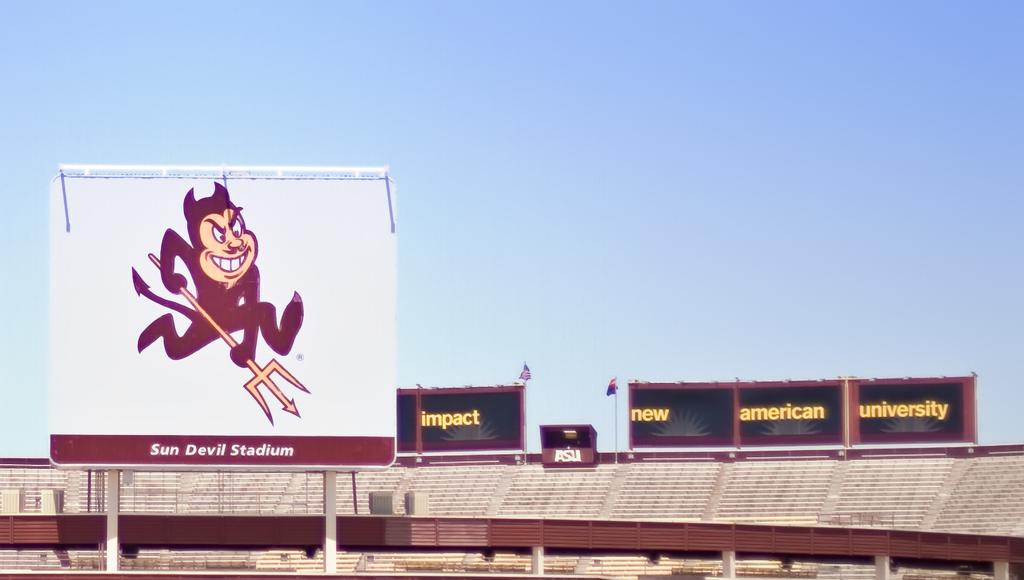What is the name of the stadium?
Give a very brief answer. Sun devil stadium. What word is in yellow furthest to the right?
Provide a short and direct response. University. 